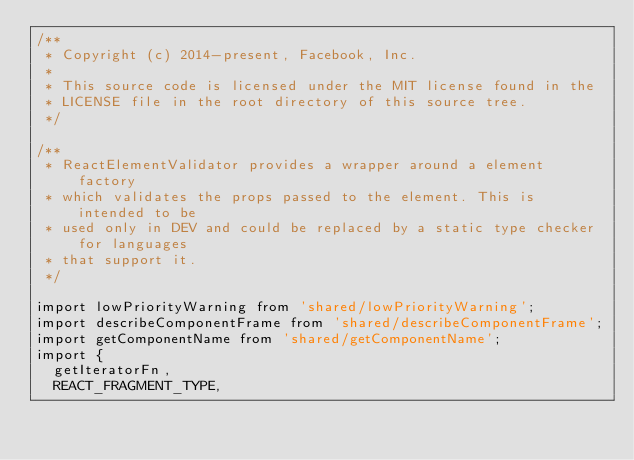Convert code to text. <code><loc_0><loc_0><loc_500><loc_500><_JavaScript_>/**
 * Copyright (c) 2014-present, Facebook, Inc.
 *
 * This source code is licensed under the MIT license found in the
 * LICENSE file in the root directory of this source tree.
 */

/**
 * ReactElementValidator provides a wrapper around a element factory
 * which validates the props passed to the element. This is intended to be
 * used only in DEV and could be replaced by a static type checker for languages
 * that support it.
 */

import lowPriorityWarning from 'shared/lowPriorityWarning';
import describeComponentFrame from 'shared/describeComponentFrame';
import getComponentName from 'shared/getComponentName';
import {
  getIteratorFn,
  REACT_FRAGMENT_TYPE,</code> 